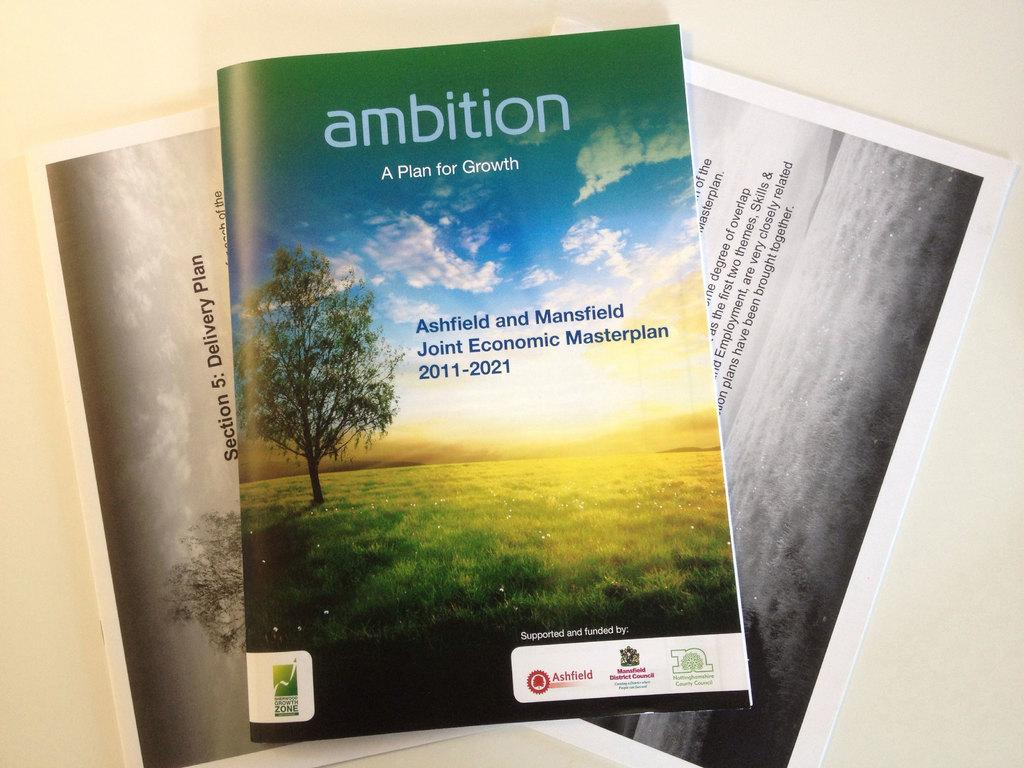<image>
Give a short and clear explanation of the subsequent image. A magazine on top of two photos that says ambition, a plan for growth 